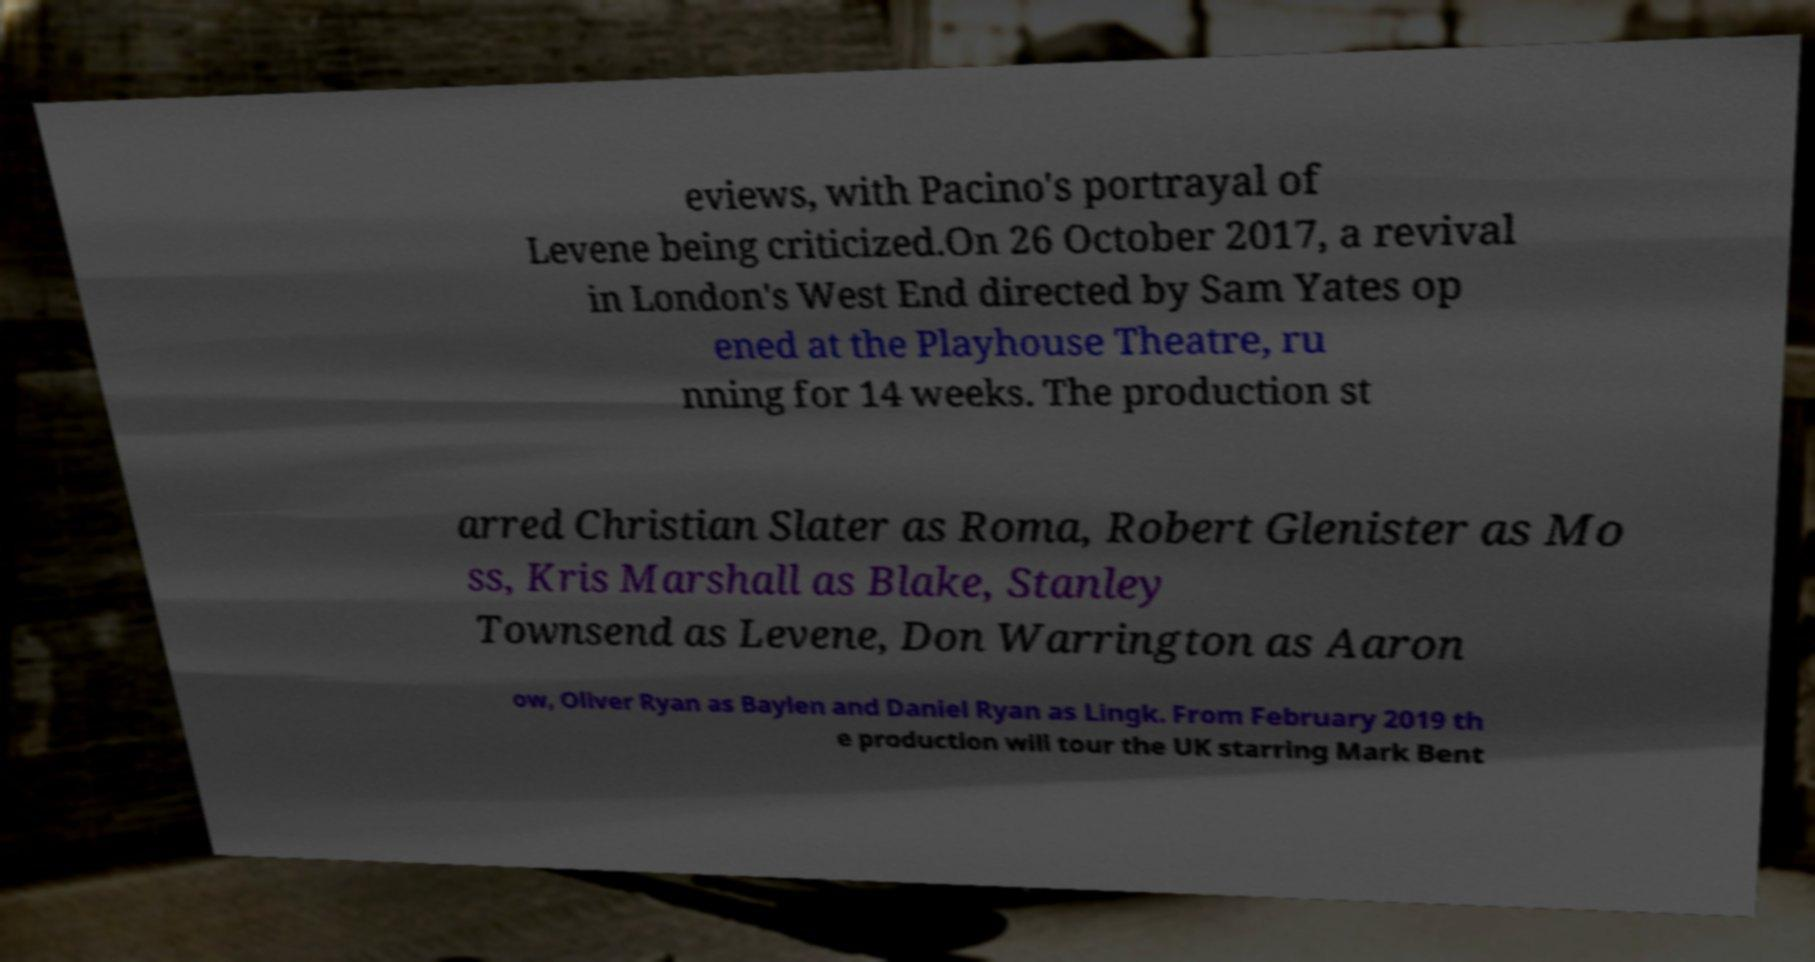I need the written content from this picture converted into text. Can you do that? eviews, with Pacino's portrayal of Levene being criticized.On 26 October 2017, a revival in London's West End directed by Sam Yates op ened at the Playhouse Theatre, ru nning for 14 weeks. The production st arred Christian Slater as Roma, Robert Glenister as Mo ss, Kris Marshall as Blake, Stanley Townsend as Levene, Don Warrington as Aaron ow, Oliver Ryan as Baylen and Daniel Ryan as Lingk. From February 2019 th e production will tour the UK starring Mark Bent 